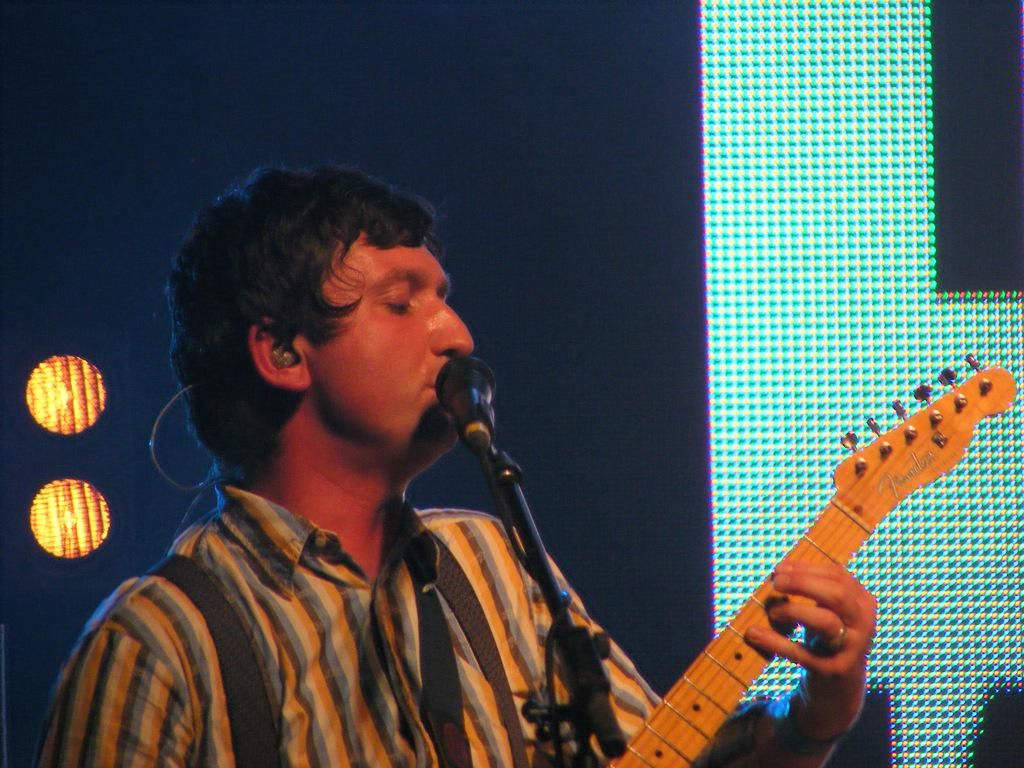What is the man in the image doing? The man is singing on a microphone. What object is the man holding in the image? The man is holding a guitar. What type of design can be seen on the sky in the image? There is no design on the sky in the image, as the sky is not mentioned in the provided facts. 